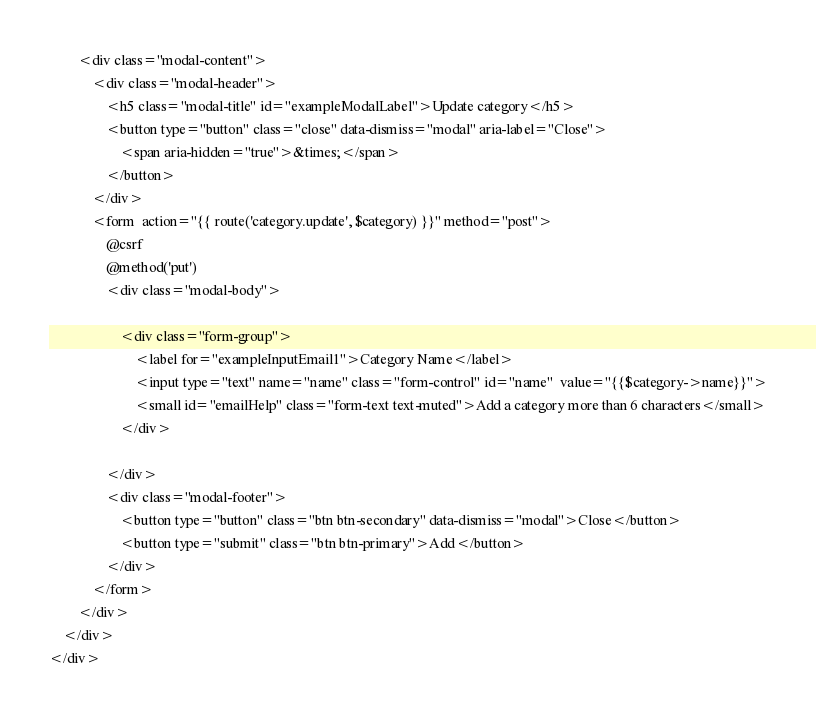Convert code to text. <code><loc_0><loc_0><loc_500><loc_500><_PHP_>        <div class="modal-content">
            <div class="modal-header">
                <h5 class="modal-title" id="exampleModalLabel">Update category</h5>
                <button type="button" class="close" data-dismiss="modal" aria-label="Close">
                    <span aria-hidden="true">&times;</span>
                </button>
            </div>
            <form  action="{{ route('category.update', $category) }}" method="post">
                @csrf
                @method('put')
                <div class="modal-body">

                    <div class="form-group">
                        <label for="exampleInputEmail1">Category Name</label>
                        <input type="text" name="name" class="form-control" id="name"  value="{{$category->name}}">
                        <small id="emailHelp" class="form-text text-muted">Add a category more than 6 characters</small>
                    </div>

                </div>
                <div class="modal-footer">
                    <button type="button" class="btn btn-secondary" data-dismiss="modal">Close</button>
                    <button type="submit" class="btn btn-primary">Add</button>
                </div>
            </form>
        </div>
    </div>
</div>
</code> 